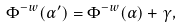<formula> <loc_0><loc_0><loc_500><loc_500>\Phi ^ { - w } ( \alpha ^ { \prime } ) = \Phi ^ { - w } ( \alpha ) + \gamma ,</formula> 